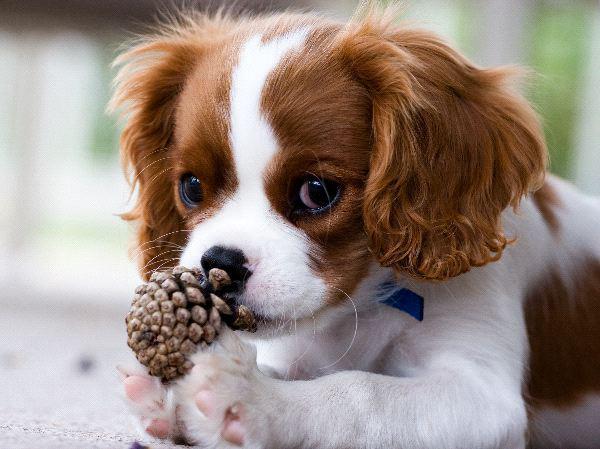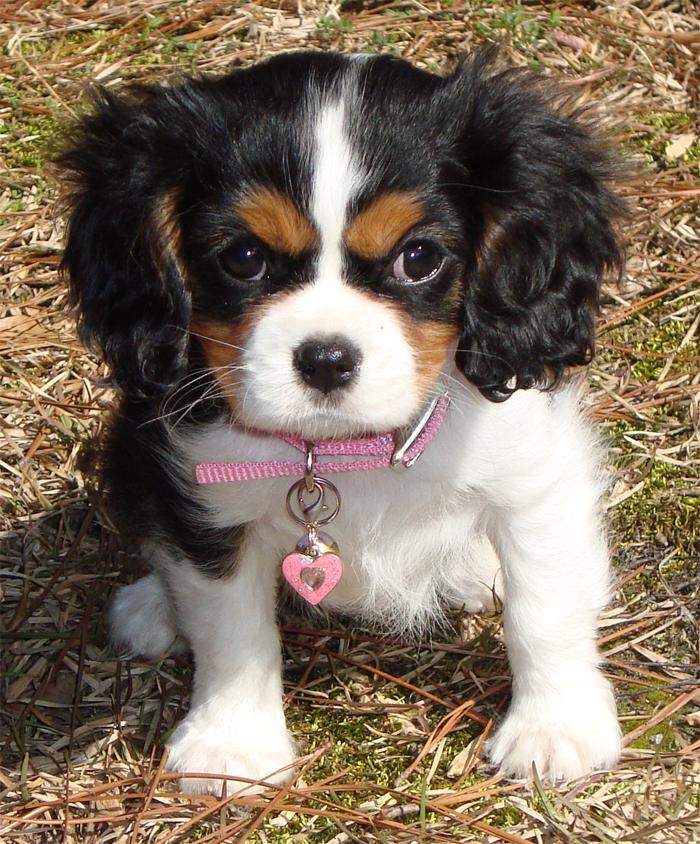The first image is the image on the left, the second image is the image on the right. Analyze the images presented: Is the assertion "There are atleast 4 cute dogs total" valid? Answer yes or no. No. The first image is the image on the left, the second image is the image on the right. Assess this claim about the two images: "There are at most two dogs.". Correct or not? Answer yes or no. Yes. 